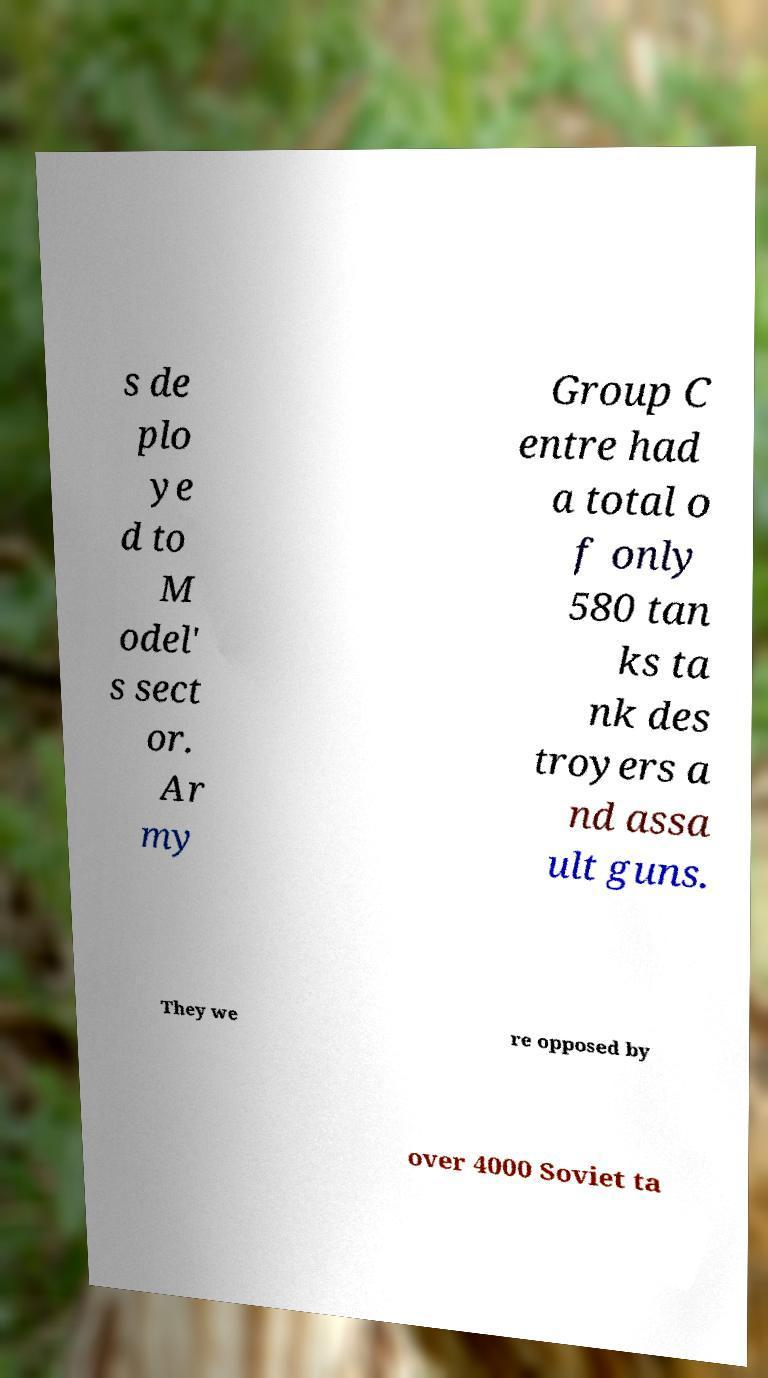Could you assist in decoding the text presented in this image and type it out clearly? s de plo ye d to M odel' s sect or. Ar my Group C entre had a total o f only 580 tan ks ta nk des troyers a nd assa ult guns. They we re opposed by over 4000 Soviet ta 